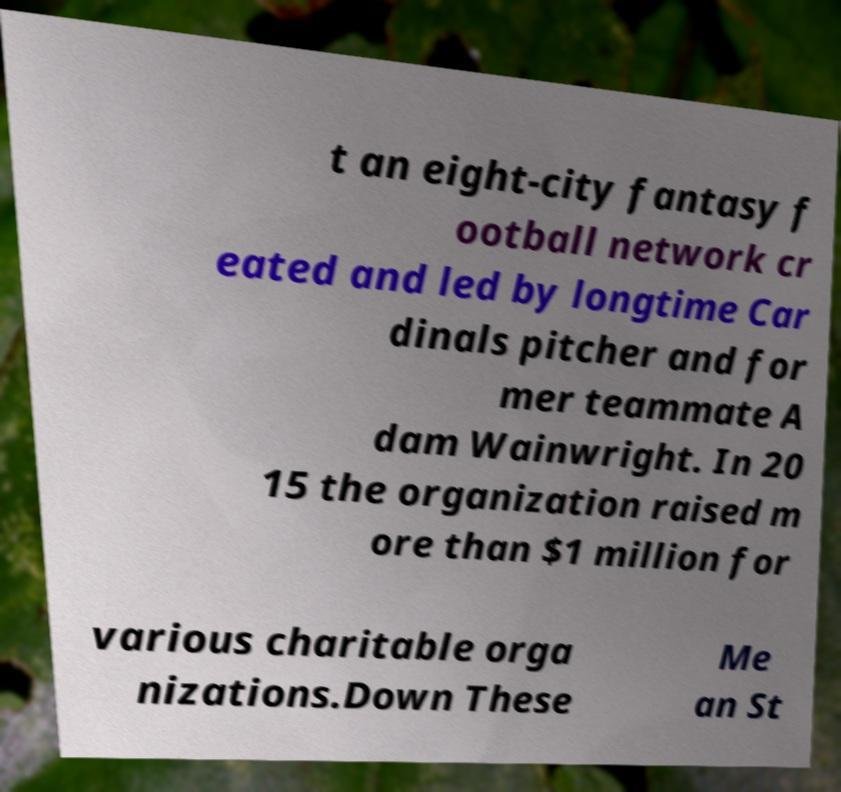What messages or text are displayed in this image? I need them in a readable, typed format. t an eight-city fantasy f ootball network cr eated and led by longtime Car dinals pitcher and for mer teammate A dam Wainwright. In 20 15 the organization raised m ore than $1 million for various charitable orga nizations.Down These Me an St 